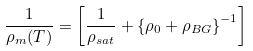Convert formula to latex. <formula><loc_0><loc_0><loc_500><loc_500>\frac { 1 } { \rho _ { m } ( T ) } = \left [ \frac { 1 } { \rho _ { s a t } } + \left \{ \rho _ { 0 } + \rho _ { B G } \right \} ^ { - 1 } \right ]</formula> 